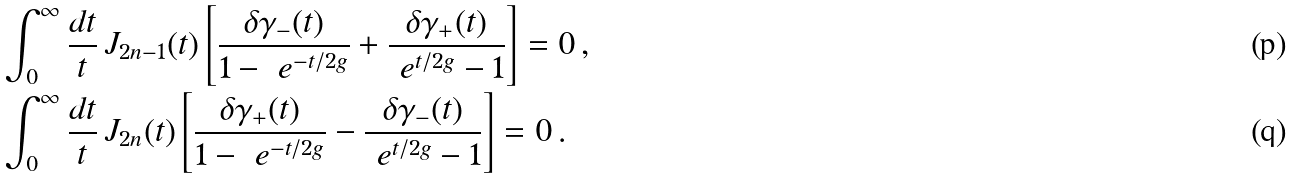Convert formula to latex. <formula><loc_0><loc_0><loc_500><loc_500>& \int _ { 0 } ^ { \infty } \frac { d t } { t } \, J _ { 2 n - 1 } ( t ) \left [ \frac { \delta \gamma _ { - } ( t ) } { 1 - \ e ^ { - t / 2 g } } + \frac { \delta \gamma _ { + } ( t ) } { \ e ^ { t / 2 g } - 1 } \right ] = 0 \, , \\ & \int _ { 0 } ^ { \infty } \frac { d t } { t } \, J _ { 2 n } ( t ) \left [ \frac { \delta \gamma _ { + } ( t ) } { 1 - \ e ^ { - t / 2 g } } - \frac { \delta \gamma _ { - } ( t ) } { \ e ^ { t / 2 g } - 1 } \right ] = 0 \, .</formula> 